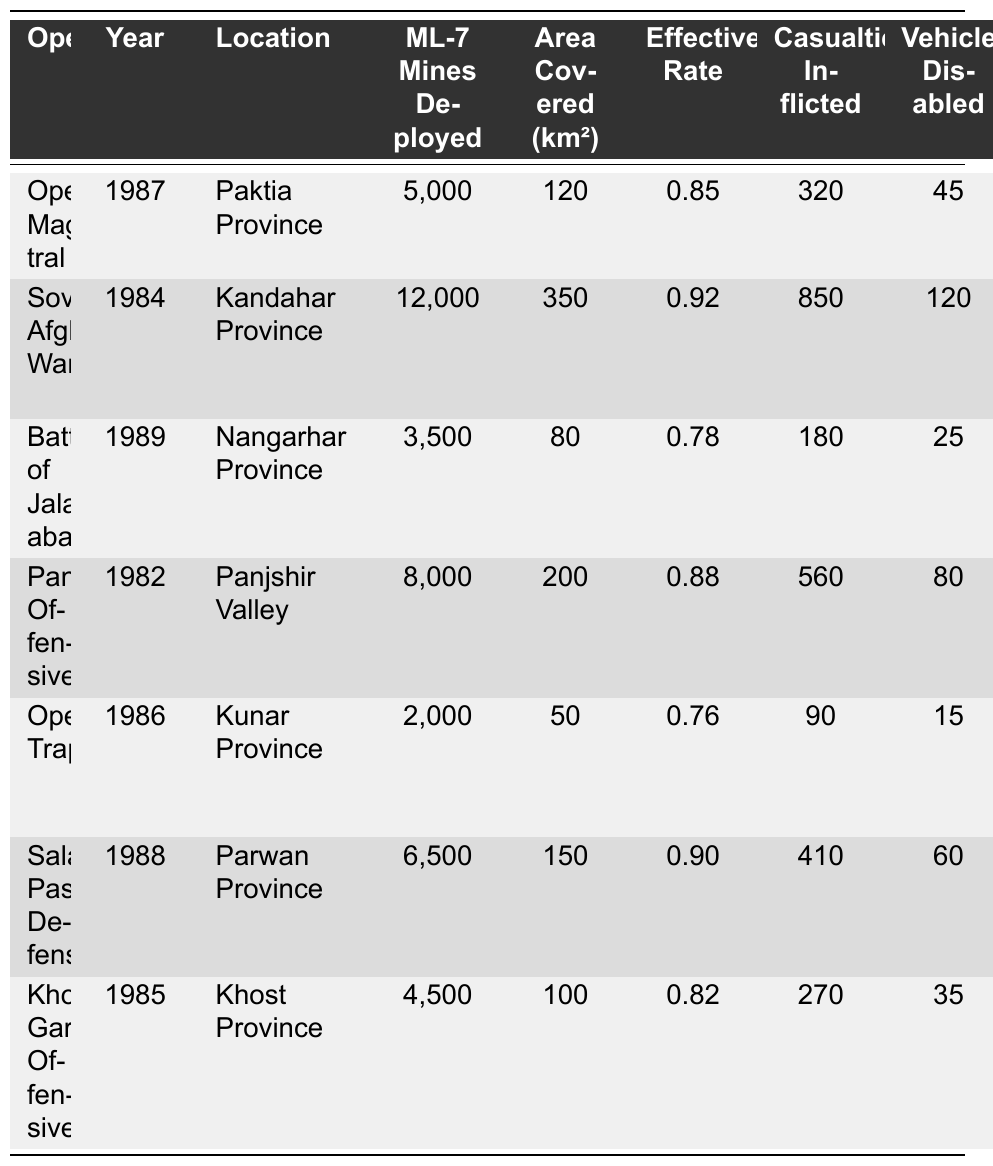What was the effectiveness rate of the Salang Pass Defense operation? The effectiveness rate for the Salang Pass Defense operation is located in the corresponding row under the "Effectiveness Rate" column. For this operation, it is 0.90.
Answer: 0.90 Which operation had the highest number of ML-7 mines deployed? By comparing the "ML-7 Mines Deployed" column, the Soviet-Afghan War shows the highest number with 12,000 mines.
Answer: Soviet-Afghan War What is the total number of casualties inflicted across all operations? To find the total casualties, sum the values in the "Casualties Inflicted" column: 320 + 850 + 180 + 560 + 90 + 410 + 270 = 2,780.
Answer: 2,780 Did the Khost-Gardez Offensive result in more vehicles disabled than the Battle of Jalalabad? By checking the "Vehicles Disabled" column, Khost-Gardez Offensive disabled 35 vehicles, whereas Battle of Jalalabad disabled 25 vehicles. Therefore, yes.
Answer: Yes What is the average area covered (in km²) by the mined areas during these operations? To find the average, sum the areas covered: 120 + 350 + 80 + 200 + 50 + 150 + 100 = 1,050. Then, divide by the number of operations (7): 1,050 / 7 = 150.
Answer: 150 Which operation had the least casualties inflicted, and how many were there? The least casualties can be found by looking at the "Casualties Inflicted" column. The Operation Trap has the least with 90 casualties.
Answer: Operation Trap, 90 If we consider the mines deployed in the Soviet-Afghan War and the Salang Pass Defense, what is the difference in the number of mines deployed? The mines deployed in the Soviet-Afghan War is 12,000 and in the Salang Pass Defense is 6,500. The difference is 12,000 - 6,500 = 5,500.
Answer: 5,500 How long did it take to clear mines in the Panjshir Offensives compared to the Operation Trap? The duration for Panjshir Offensives was 90 days and for Operation Trap was 30 days, which shows a difference of 90 - 30 = 60 days.
Answer: 60 days What accompanying mine types were used in the Battle of Jalalabad? The accompanying mine types for the Battle of Jalalabad are listed in the "Accompanying Mine Types" column as MON-50 and OZM-72.
Answer: MON-50, OZM-72 Which operation had a higher effectiveness rate: the Operation Magistral or the Panjshir Offensives? By comparing the effectiveness rates, Operation Magistral has a rate of 0.85 and Panjshir Offensives has a rate of 0.88. Therefore, Panjshir Offensives is higher.
Answer: Panjshir Offensives 